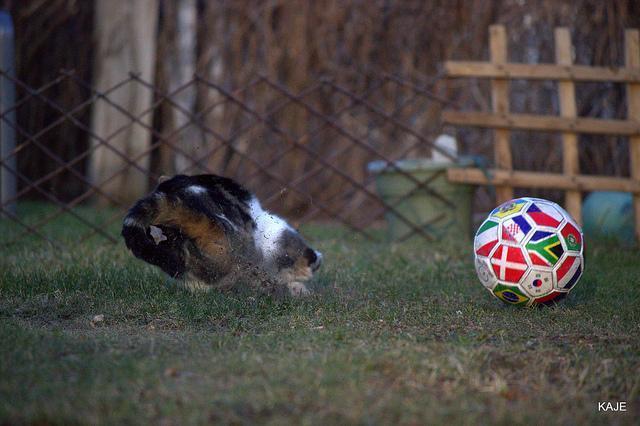How many sports balls can be seen?
Give a very brief answer. 2. How many chair legs are touching only the orange surface of the floor?
Give a very brief answer. 0. 